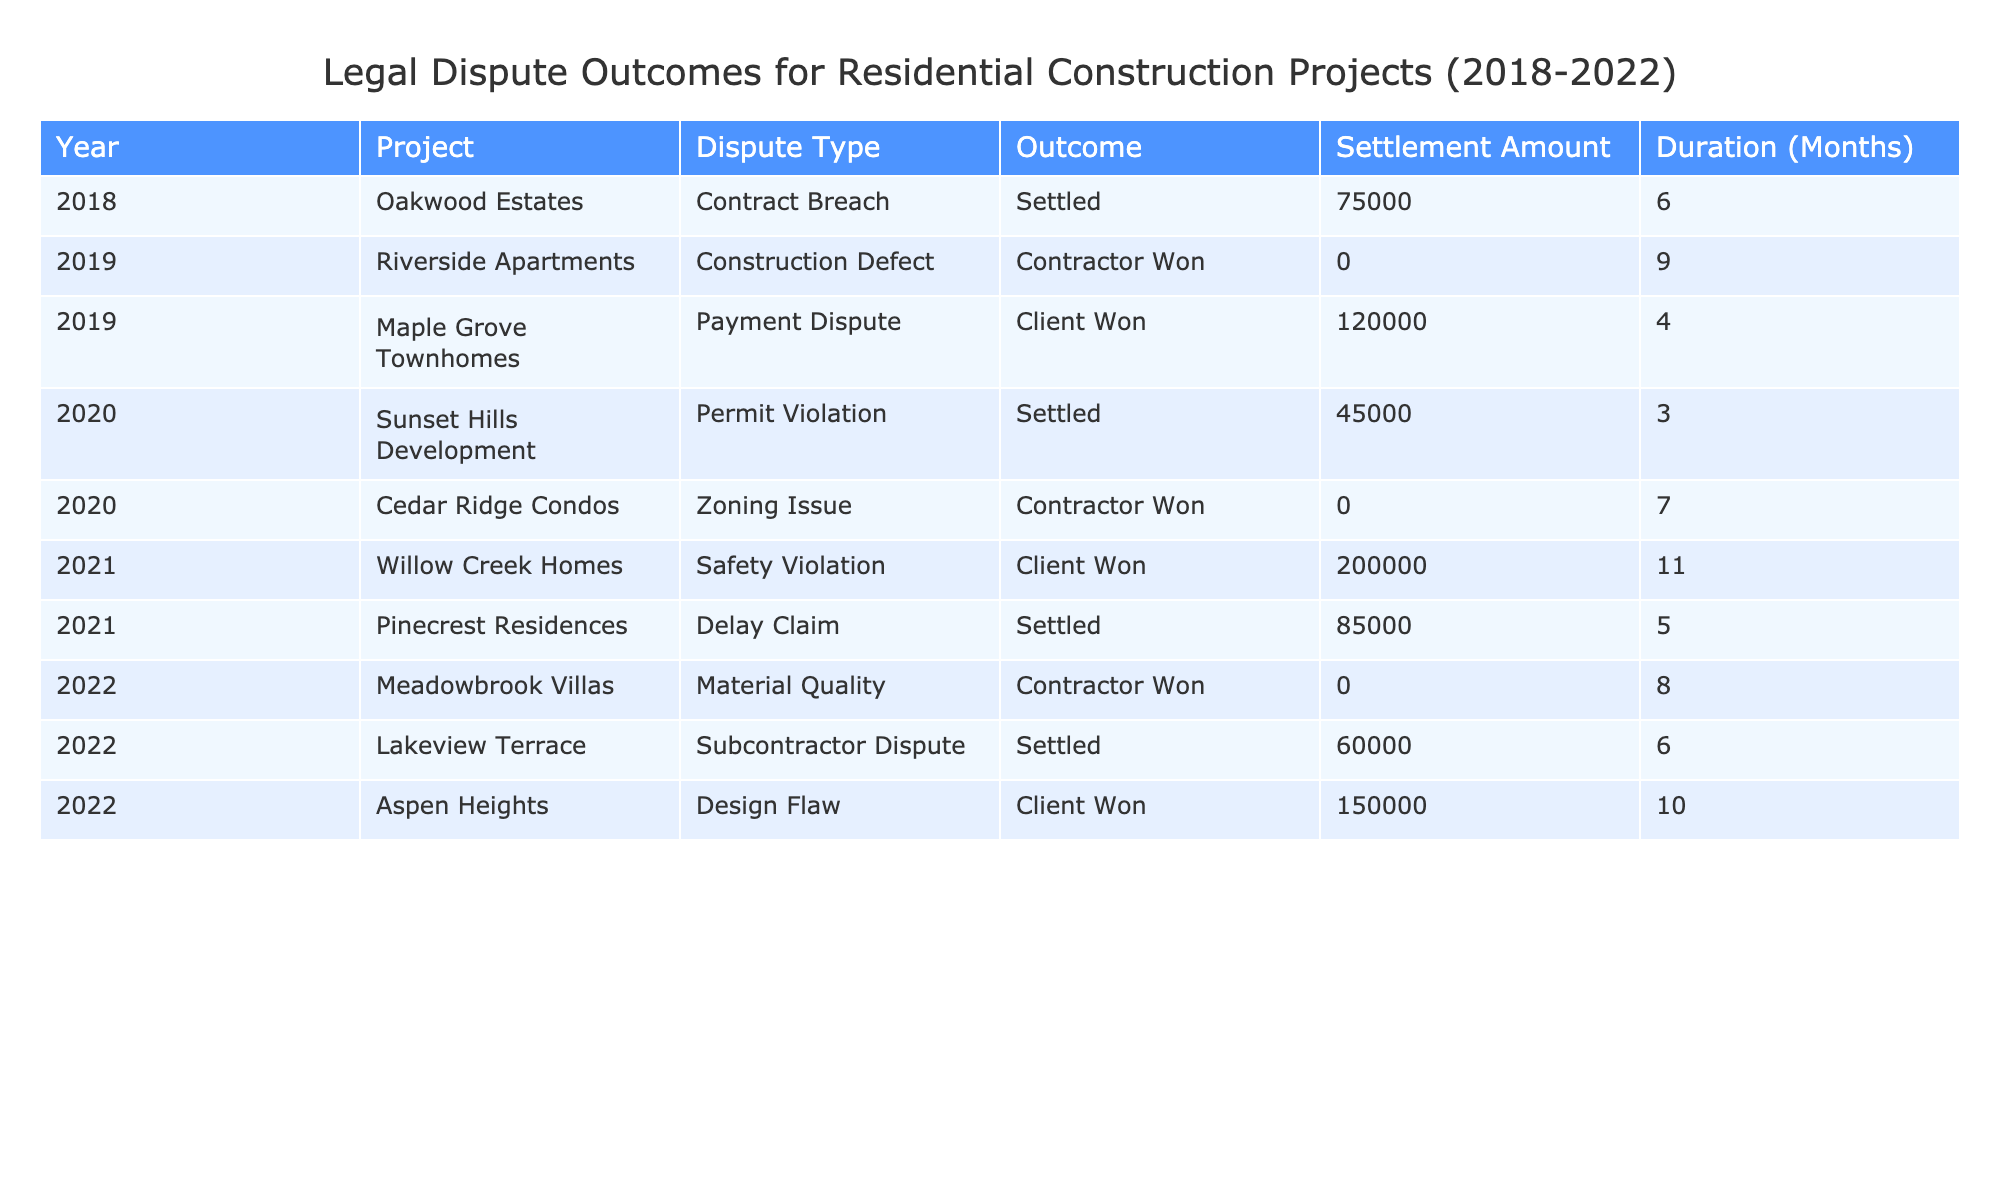What was the total settlement amount for disputes resolved in 2018? In 2018, there was one case (Oakwood Estates) that was settled with a settlement amount of $75,000. Since there are no other cases from 2018, the total settlement amount is simply $75,000.
Answer: 75000 How many disputes did the contractor win between 2019 and 2022? The table shows that the contractor won in 2019 (1 case) and 2020 (1 case), and again in 2022 (1 case). Summing these gives: 1 + 1 + 1 = 3 cases won by the contractor.
Answer: 3 What is the maximum settlement amount recorded in the table? Reviewing the settlement amounts, the maximum is found by scanning through the values: $120,000, $75,000, $200,000, $85,000, $150,000, and $60,000. The highest value here is $200,000.
Answer: 200000 Which year had the longest duration to settle a dispute? The durations listed indicate that in 2021, there was a dispute that lasted 11 months (Willow Creek Homes), which is longer than any other dispute recorded in the table.
Answer: 2021 Is it true that all disputes involving client wins resulted in a settlement amount? From the data, we see that in 2019 (Maple Grove Townhomes), the client won with a settlement amount of $120,000, and in 2021 (Willow Creek Homes), the client won with $200,000. Therefore, it is false that all disputes involving client wins resulted in a settlement amount, as the zoning issue did not have a settlement amount listed when the contractor won.
Answer: No What is the average duration (in months) of disputes when the client won? The durations for client-won disputes are 4 months (Maple Grove Townhomes), 11 months (Willow Creek Homes), and 10 months (Aspen Heights). The average is calculated by summing these durations (4 + 11 + 10 = 25) and dividing by the number of cases (3), resulting in an average of 25/3 = 8.33 months, which can be rounded to approximately 8 months.
Answer: 8 Was there any dispute in 2020 that did not require any settlement amount? In 2020, the Cedar Ridge Condos case was won by the contractor with a settlement amount of $0. Therefore, there was indeed a dispute in 2020 that did not require any settlement amount.
Answer: Yes How many disputes were settled in total from 2018 to 2022? Examining the table, disputes were settled in the years 2018 (1 case), 2020 (1 case), 2021 (1 case), and 2022 (2 cases). Adding these gives a total of: 1 + 1 + 1 + 2 = 5 settled disputes.
Answer: 5 What percentage of disputes were won by clients from 2018 to 2022? The total number of disputes is 8 (sum of all listed rows). The client won in 3 cases (Maple Grove Townhomes, Willow Creek Homes, Aspen Heights). The percentage is calculated by (3 wins by clients / 8 total disputes) * 100, resulting in 37.5%.
Answer: 37.5% 